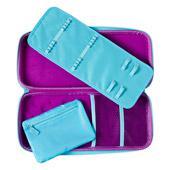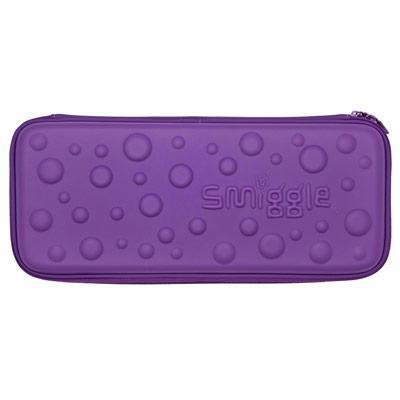The first image is the image on the left, the second image is the image on the right. Analyze the images presented: Is the assertion "There is at least one pencil case open with no visible stationery inside." valid? Answer yes or no. Yes. The first image is the image on the left, the second image is the image on the right. Analyze the images presented: Is the assertion "There is a pink case in each of the photos, one that is closed and has blue dots on it and one of which is open to show the contents." valid? Answer yes or no. No. 